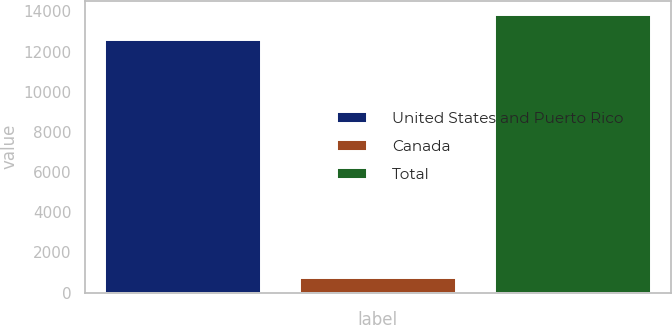Convert chart to OTSL. <chart><loc_0><loc_0><loc_500><loc_500><bar_chart><fcel>United States and Puerto Rico<fcel>Canada<fcel>Total<nl><fcel>12566<fcel>744<fcel>13822.6<nl></chart> 